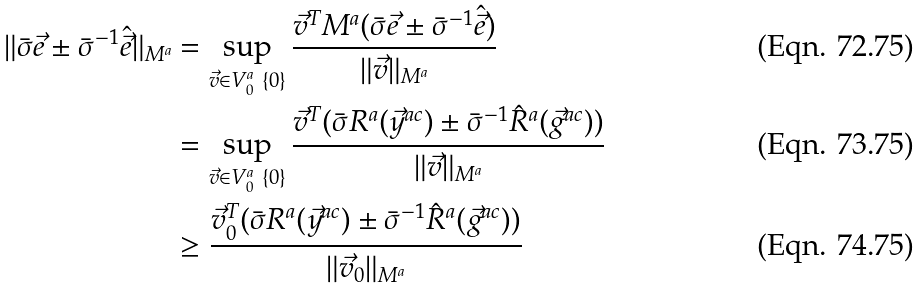Convert formula to latex. <formula><loc_0><loc_0><loc_500><loc_500>\| \bar { \sigma } \vec { e } \pm \bar { \sigma } ^ { - 1 } \hat { \vec { e } } \| _ { M ^ { a } } & = \sup _ { \vec { v } \in V ^ { a } _ { 0 } \ \{ 0 \} } \frac { \vec { v } ^ { T } M ^ { a } ( \bar { \sigma } \vec { e } \pm \bar { \sigma } ^ { - 1 } \hat { \vec { e } } ) } { \| \vec { v } \| _ { M ^ { a } } } \\ & = \sup _ { \vec { v } \in V ^ { a } _ { 0 } \ \{ 0 \} } \frac { \vec { v } ^ { T } ( \bar { \sigma } R ^ { a } ( \vec { y } ^ { a c } ) \pm \bar { \sigma } ^ { - 1 } \hat { R } ^ { a } ( \vec { g } ^ { a c } ) ) } { \| \vec { v } \| _ { M ^ { a } } } \\ & \geq \frac { \vec { v } _ { 0 } ^ { T } ( \bar { \sigma } R ^ { a } ( \vec { y } ^ { a c } ) \pm \bar { \sigma } ^ { - 1 } \hat { R } ^ { a } ( \vec { g } ^ { a c } ) ) } { \| \vec { v } _ { 0 } \| _ { M ^ { a } } }</formula> 